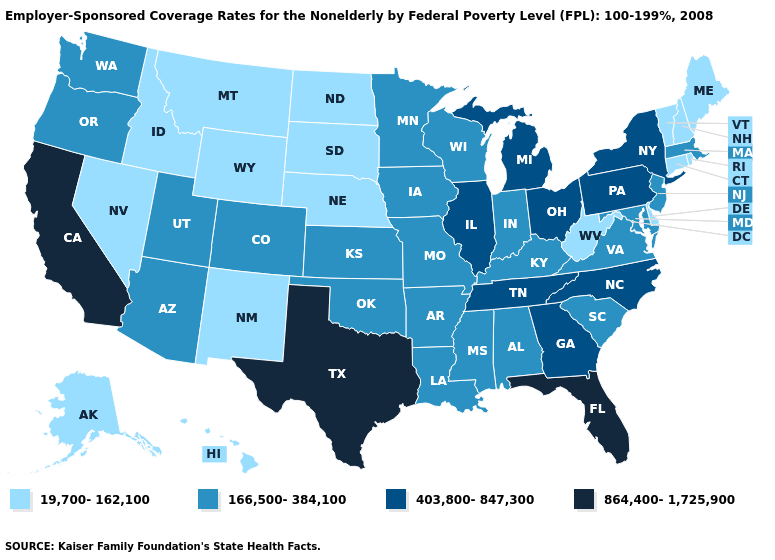Name the states that have a value in the range 166,500-384,100?
Quick response, please. Alabama, Arizona, Arkansas, Colorado, Indiana, Iowa, Kansas, Kentucky, Louisiana, Maryland, Massachusetts, Minnesota, Mississippi, Missouri, New Jersey, Oklahoma, Oregon, South Carolina, Utah, Virginia, Washington, Wisconsin. Does Iowa have the highest value in the MidWest?
Concise answer only. No. Name the states that have a value in the range 403,800-847,300?
Give a very brief answer. Georgia, Illinois, Michigan, New York, North Carolina, Ohio, Pennsylvania, Tennessee. What is the value of South Carolina?
Keep it brief. 166,500-384,100. What is the value of Nebraska?
Be succinct. 19,700-162,100. Is the legend a continuous bar?
Write a very short answer. No. What is the highest value in the USA?
Give a very brief answer. 864,400-1,725,900. What is the value of Kentucky?
Concise answer only. 166,500-384,100. Does New Jersey have the lowest value in the Northeast?
Be succinct. No. Which states have the highest value in the USA?
Give a very brief answer. California, Florida, Texas. Which states have the highest value in the USA?
Concise answer only. California, Florida, Texas. Does the map have missing data?
Short answer required. No. Does Washington have the lowest value in the West?
Keep it brief. No. Is the legend a continuous bar?
Be succinct. No. What is the value of Florida?
Answer briefly. 864,400-1,725,900. 